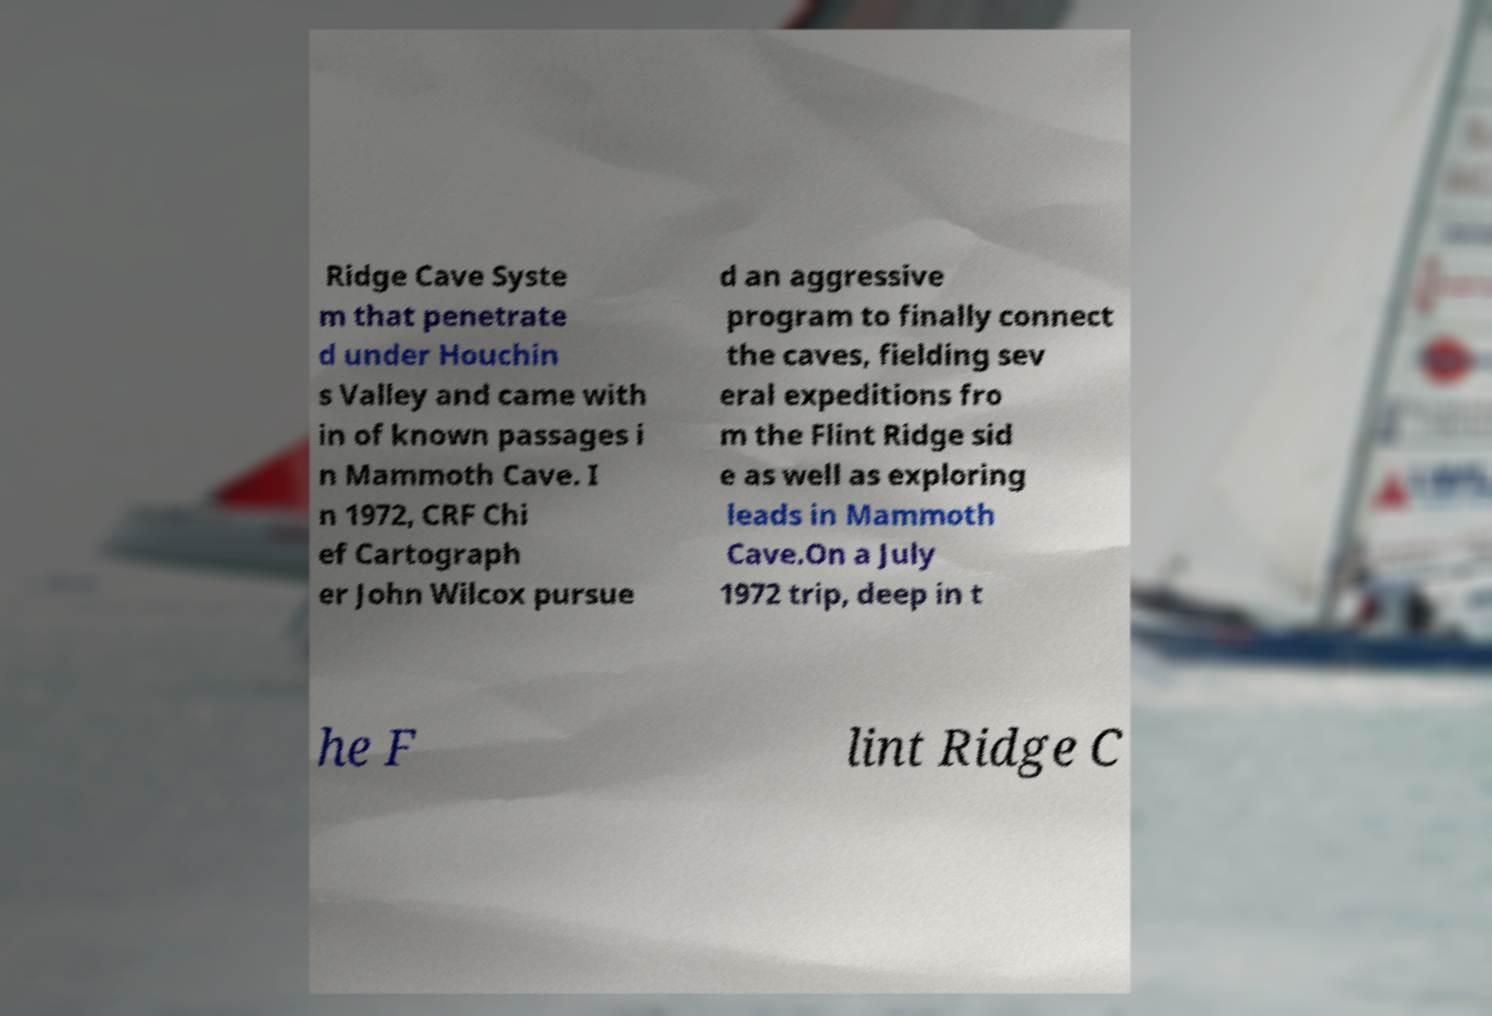Could you assist in decoding the text presented in this image and type it out clearly? Ridge Cave Syste m that penetrate d under Houchin s Valley and came with in of known passages i n Mammoth Cave. I n 1972, CRF Chi ef Cartograph er John Wilcox pursue d an aggressive program to finally connect the caves, fielding sev eral expeditions fro m the Flint Ridge sid e as well as exploring leads in Mammoth Cave.On a July 1972 trip, deep in t he F lint Ridge C 